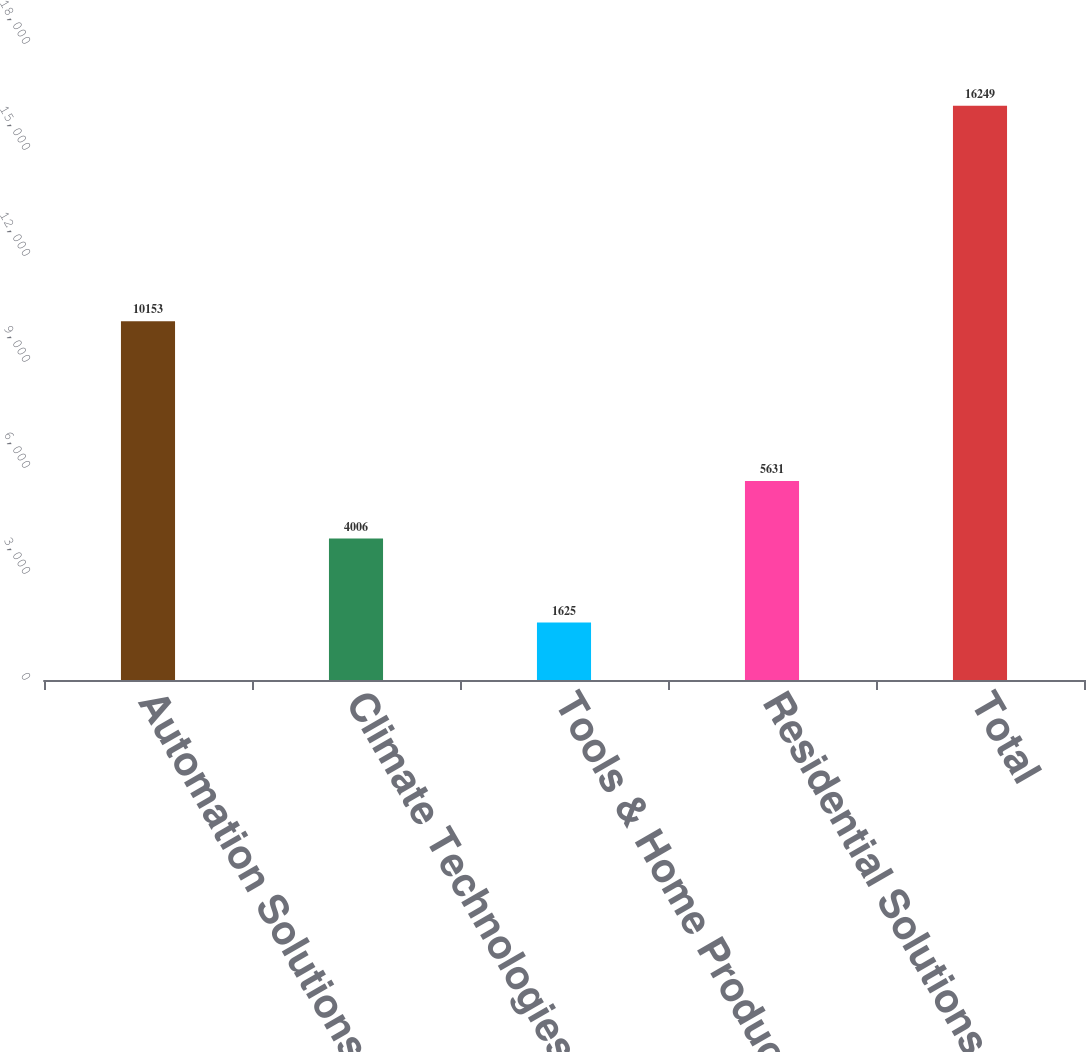Convert chart to OTSL. <chart><loc_0><loc_0><loc_500><loc_500><bar_chart><fcel>Automation Solutions<fcel>Climate Technologies<fcel>Tools & Home Products<fcel>Residential Solutions<fcel>Total<nl><fcel>10153<fcel>4006<fcel>1625<fcel>5631<fcel>16249<nl></chart> 